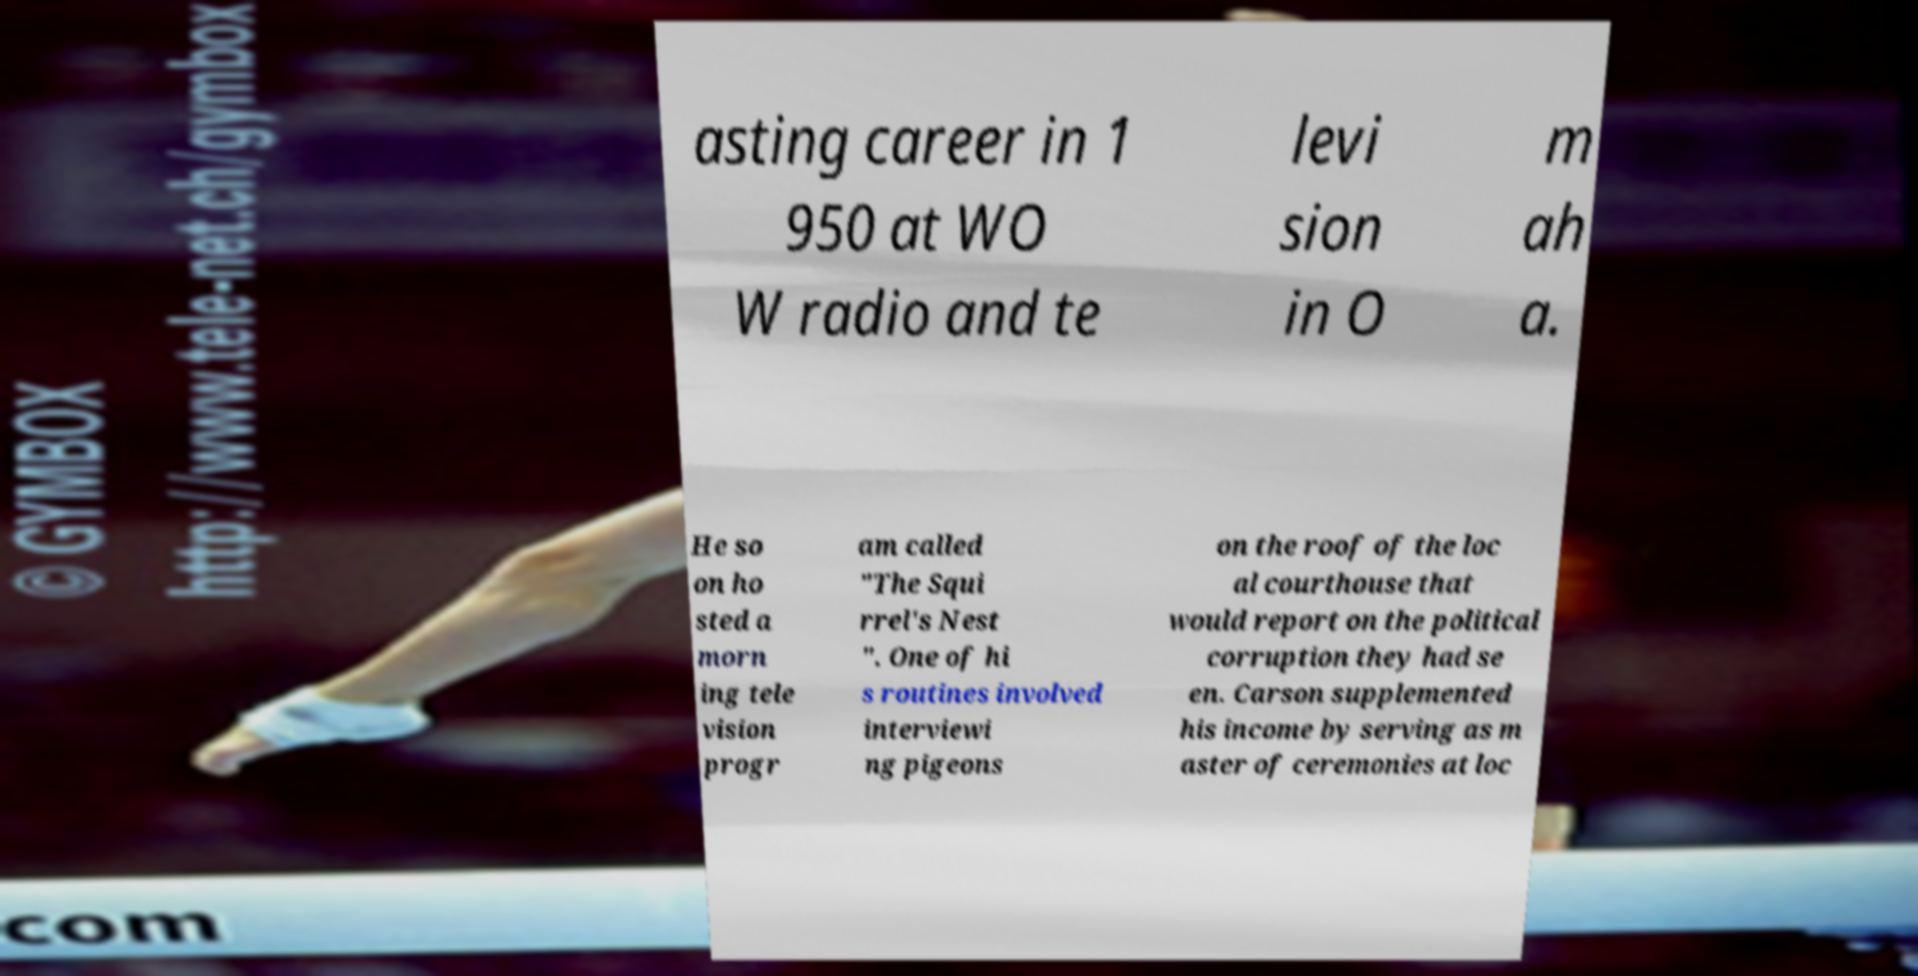Please identify and transcribe the text found in this image. asting career in 1 950 at WO W radio and te levi sion in O m ah a. He so on ho sted a morn ing tele vision progr am called "The Squi rrel's Nest ". One of hi s routines involved interviewi ng pigeons on the roof of the loc al courthouse that would report on the political corruption they had se en. Carson supplemented his income by serving as m aster of ceremonies at loc 